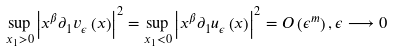Convert formula to latex. <formula><loc_0><loc_0><loc_500><loc_500>\underset { x _ { 1 } > 0 } { \sup } \left | x ^ { \beta } \partial _ { 1 } v _ { \epsilon } \left ( x \right ) \right | ^ { 2 } = \underset { x _ { 1 } < 0 } { \sup } \left | x ^ { \beta } \partial _ { 1 } u _ { \epsilon } \left ( x \right ) \right | ^ { 2 } = O \left ( \epsilon ^ { m } \right ) , \epsilon \longrightarrow 0</formula> 